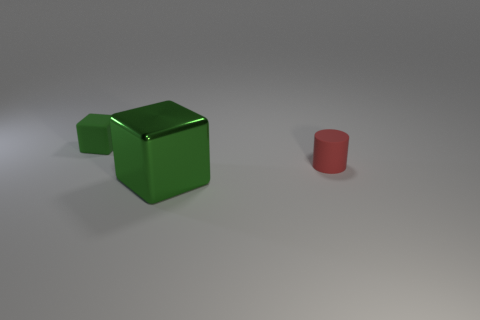Add 3 green rubber objects. How many objects exist? 6 Subtract all cubes. How many objects are left? 1 Subtract all large shiny blocks. Subtract all large green objects. How many objects are left? 1 Add 3 small green rubber things. How many small green rubber things are left? 4 Add 2 red rubber cylinders. How many red rubber cylinders exist? 3 Subtract 0 red spheres. How many objects are left? 3 